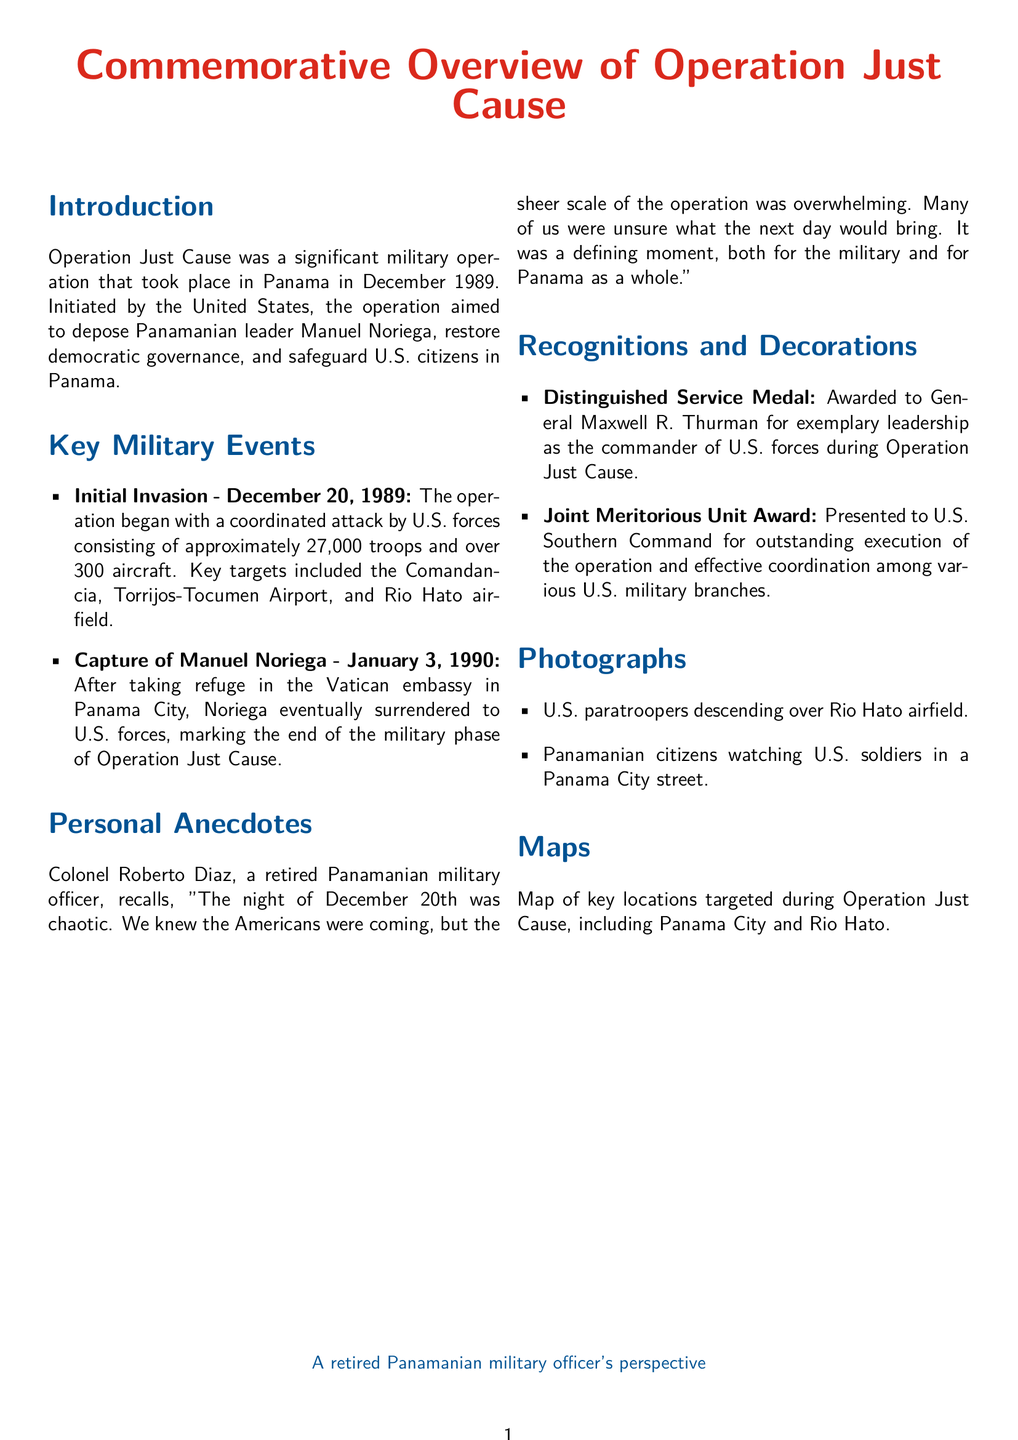what was the start date of Operation Just Cause? The document states that Operation Just Cause began on December 20, 1989.
Answer: December 20, 1989 who was the leader targeted during the operation? The targeted leader mentioned in the document is Manuel Noriega.
Answer: Manuel Noriega how many U.S. troops were involved in the operation? The document notes that approximately 27,000 troops were involved in the operation.
Answer: 27,000 what award did General Maxwell R. Thurman receive? According to the document, he received the Distinguished Service Medal.
Answer: Distinguished Service Medal what personal anecdote is shared in the document? The document includes a recollection by Colonel Roberto Diaz describing the chaotic night of December 20th.
Answer: Colonel Roberto Diaz's recollection when did Manuel Noriega surrender? The document mentions that Manuel Noriega surrendered on January 3, 1990.
Answer: January 3, 1990 which location was targeted along with the Comandancia? The document states that the Torrijos-Tocumen Airport was also targeted during the operation.
Answer: Torrijos-Tocumen Airport what recognition did the U.S. Southern Command receive? The document mentions that the U.S. Southern Command received the Joint Meritorious Unit Award.
Answer: Joint Meritorious Unit Award 